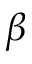Convert formula to latex. <formula><loc_0><loc_0><loc_500><loc_500>\beta</formula> 